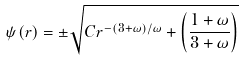<formula> <loc_0><loc_0><loc_500><loc_500>\psi ( r ) = \pm \sqrt { C r ^ { - ( 3 + \omega ) / \omega } + \left ( \frac { 1 + \omega } { 3 + \omega } \right ) }</formula> 